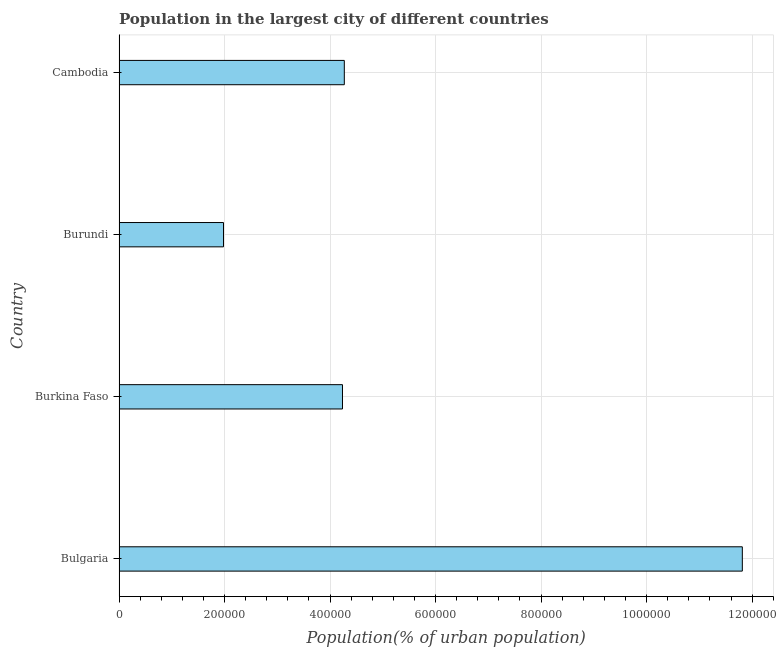Does the graph contain any zero values?
Keep it short and to the point. No. What is the title of the graph?
Offer a very short reply. Population in the largest city of different countries. What is the label or title of the X-axis?
Provide a short and direct response. Population(% of urban population). What is the label or title of the Y-axis?
Offer a terse response. Country. What is the population in largest city in Burkina Faso?
Give a very brief answer. 4.24e+05. Across all countries, what is the maximum population in largest city?
Your answer should be compact. 1.18e+06. Across all countries, what is the minimum population in largest city?
Make the answer very short. 1.98e+05. In which country was the population in largest city maximum?
Make the answer very short. Bulgaria. In which country was the population in largest city minimum?
Your answer should be very brief. Burundi. What is the sum of the population in largest city?
Provide a succinct answer. 2.23e+06. What is the difference between the population in largest city in Burkina Faso and Cambodia?
Provide a short and direct response. -3463. What is the average population in largest city per country?
Ensure brevity in your answer.  5.57e+05. What is the median population in largest city?
Keep it short and to the point. 4.25e+05. In how many countries, is the population in largest city greater than 760000 %?
Make the answer very short. 1. Is the population in largest city in Burundi less than that in Cambodia?
Make the answer very short. Yes. What is the difference between the highest and the second highest population in largest city?
Ensure brevity in your answer.  7.54e+05. Is the sum of the population in largest city in Burkina Faso and Burundi greater than the maximum population in largest city across all countries?
Keep it short and to the point. No. What is the difference between the highest and the lowest population in largest city?
Give a very brief answer. 9.83e+05. How many bars are there?
Give a very brief answer. 4. How many countries are there in the graph?
Offer a terse response. 4. What is the Population(% of urban population) in Bulgaria?
Keep it short and to the point. 1.18e+06. What is the Population(% of urban population) in Burkina Faso?
Provide a short and direct response. 4.24e+05. What is the Population(% of urban population) of Burundi?
Offer a very short reply. 1.98e+05. What is the Population(% of urban population) of Cambodia?
Your answer should be very brief. 4.27e+05. What is the difference between the Population(% of urban population) in Bulgaria and Burkina Faso?
Offer a terse response. 7.58e+05. What is the difference between the Population(% of urban population) in Bulgaria and Burundi?
Your answer should be compact. 9.83e+05. What is the difference between the Population(% of urban population) in Bulgaria and Cambodia?
Ensure brevity in your answer.  7.54e+05. What is the difference between the Population(% of urban population) in Burkina Faso and Burundi?
Ensure brevity in your answer.  2.26e+05. What is the difference between the Population(% of urban population) in Burkina Faso and Cambodia?
Your answer should be very brief. -3463. What is the difference between the Population(% of urban population) in Burundi and Cambodia?
Your answer should be compact. -2.29e+05. What is the ratio of the Population(% of urban population) in Bulgaria to that in Burkina Faso?
Provide a succinct answer. 2.79. What is the ratio of the Population(% of urban population) in Bulgaria to that in Burundi?
Provide a succinct answer. 5.97. What is the ratio of the Population(% of urban population) in Bulgaria to that in Cambodia?
Your answer should be compact. 2.77. What is the ratio of the Population(% of urban population) in Burkina Faso to that in Burundi?
Offer a very short reply. 2.14. What is the ratio of the Population(% of urban population) in Burundi to that in Cambodia?
Your answer should be very brief. 0.46. 